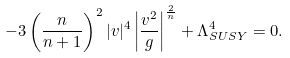Convert formula to latex. <formula><loc_0><loc_0><loc_500><loc_500>- 3 \left ( \frac { n } { n + 1 } \right ) ^ { 2 } | v | ^ { 4 } \left | \frac { v ^ { 2 } } { g } \right | ^ { \frac { 2 } { n } } + \Lambda _ { S U S Y } ^ { 4 } = 0 .</formula> 